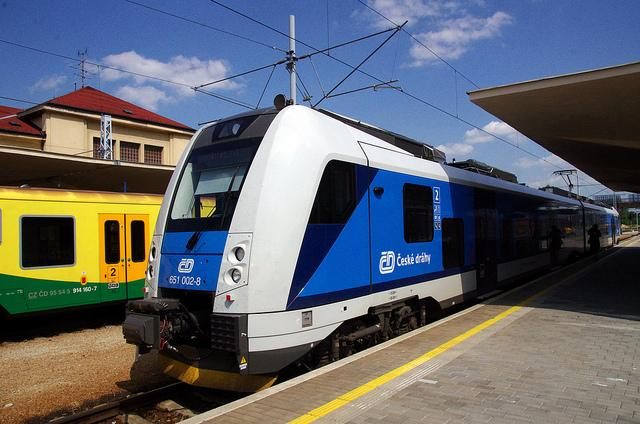Where is the train from? Please explain your reasoning. czech republic. The train is from czech. 